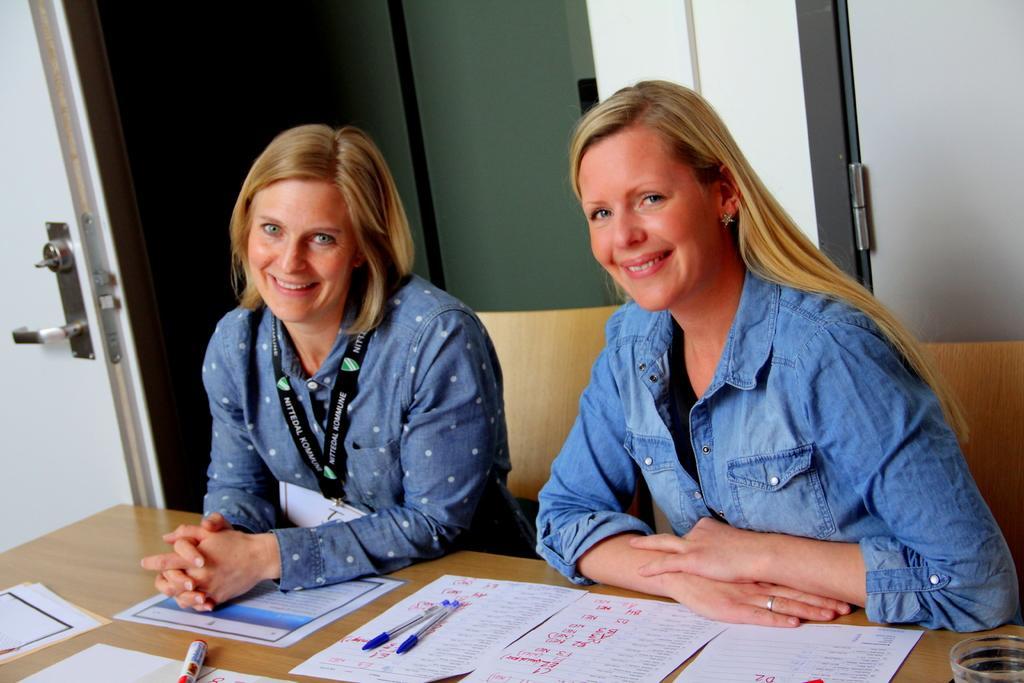Please provide a concise description of this image. In this image we can see two women sitting in front of a table. One woman is wearing a id card. On the table we can see group of paper ,pens and a glass are placed on it. In the background,we can see a door. 